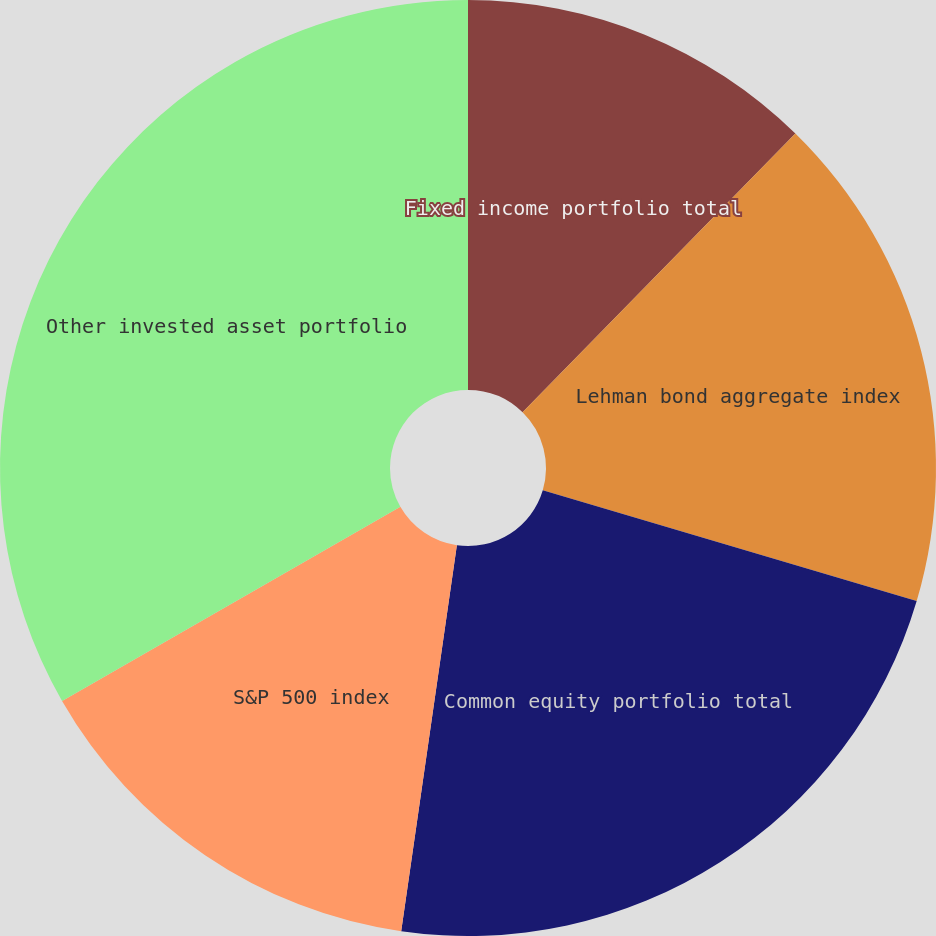<chart> <loc_0><loc_0><loc_500><loc_500><pie_chart><fcel>Fixed income portfolio total<fcel>Lehman bond aggregate index<fcel>Common equity portfolio total<fcel>S&P 500 index<fcel>Other invested asset portfolio<nl><fcel>12.33%<fcel>17.26%<fcel>22.69%<fcel>14.43%<fcel>33.29%<nl></chart> 